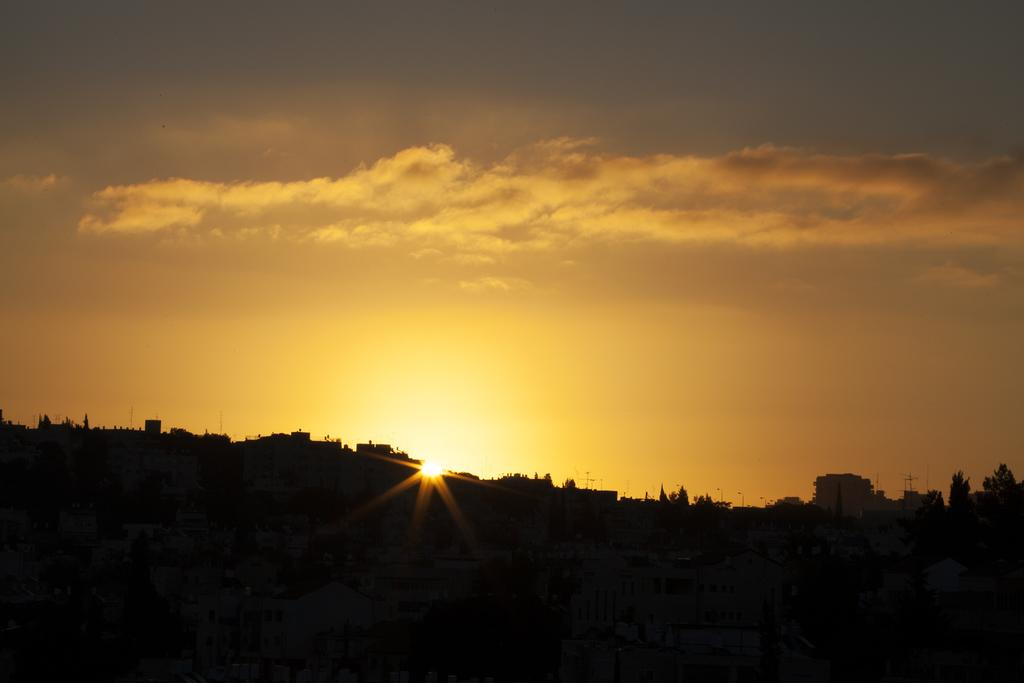What type of structures can be seen in the image? There are many houses and buildings in the image. What other natural elements are present in the image? There are trees in the image. What can be seen in the sky in the image? The sky is visible in the image, and there is a sunset with clouds present. Can you see any blood dripping from the roofs of the houses in the image? There is no blood present in the image, and the roofs of the houses are not depicted as dripping with any substance. 